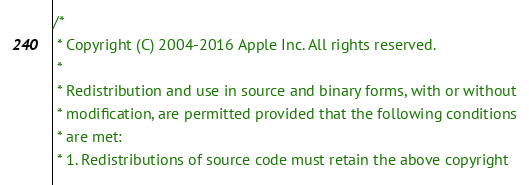<code> <loc_0><loc_0><loc_500><loc_500><_ObjectiveC_>/*
 * Copyright (C) 2004-2016 Apple Inc. All rights reserved.
 *
 * Redistribution and use in source and binary forms, with or without
 * modification, are permitted provided that the following conditions
 * are met:
 * 1. Redistributions of source code must retain the above copyright</code> 